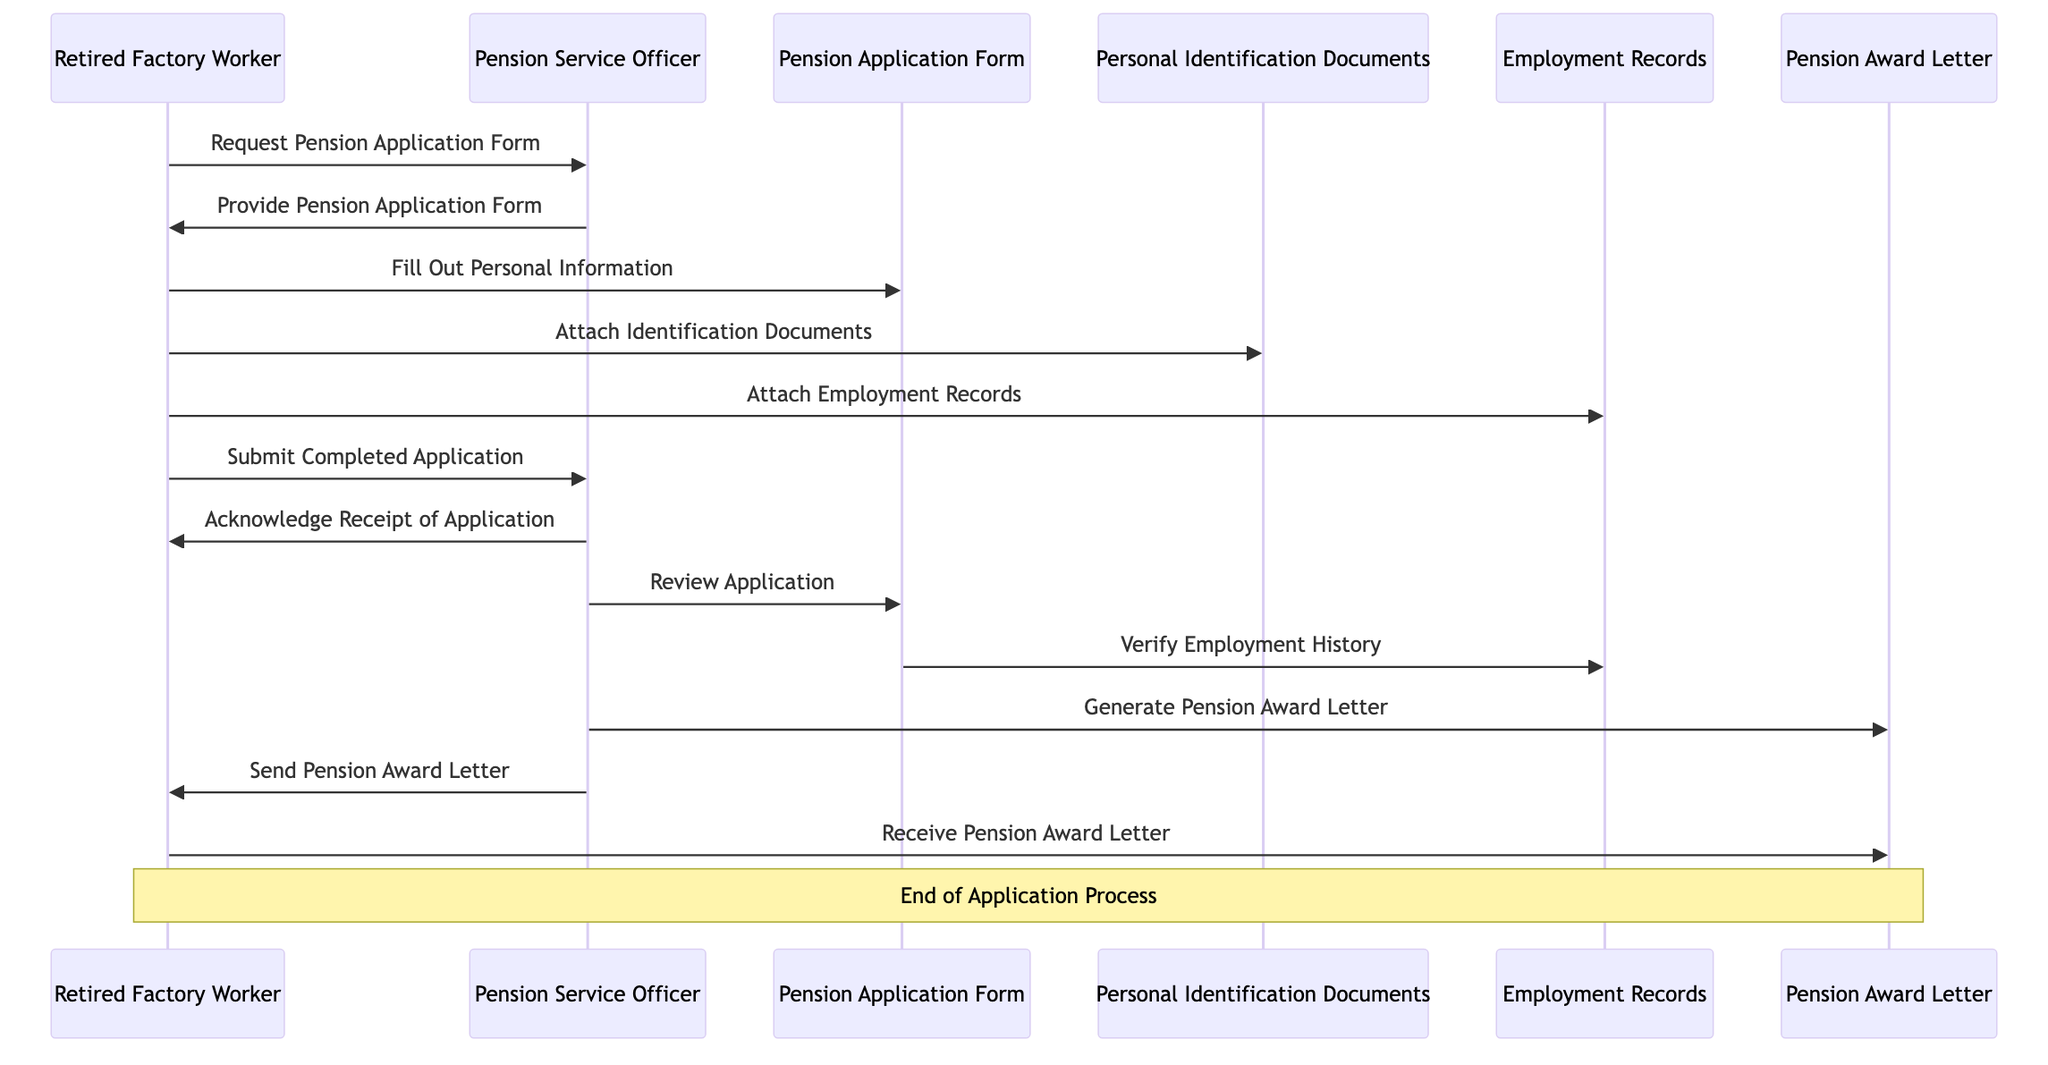What is the first action taken by the Retired Factory Worker? The first action taken by the Retired Factory Worker in the diagram is to "Request Pension Application Form," which initiates the application process.
Answer: Request Pension Application Form How many objects are involved in the application process? The diagram lists four objects: Pension Application Form, Personal Identification Documents, Employment Records, and Pension Award Letter. Therefore, the total number of objects is four.
Answer: 4 What does the Pension Service Officer do after acknowledging receipt of the application? After acknowledging receipt of the application, the Pension Service Officer reviews the application to ensure all necessary information is provided before proceeding to generate the Pension Award Letter.
Answer: Review Application Which document requires verification of employment history? The Pension Application Form is responsible for verifying the Employment Records to confirm the applicant's employment history.
Answer: Employment Records How many messages are exchanged between the actors in total? By counting all the messages in the sequence diagram, we find that a total of eleven messages are exchanged between the Retired Factory Worker and the Pension Service Officer.
Answer: 11 What is the last action taken by the Retired Factory Worker? The last action taken by the Retired Factory Worker in the sequence is "Receive Pension Award Letter," which concludes the application process.
Answer: Receive Pension Award Letter What role does the Pension Service Officer play in generating the Pension Award Letter? The Pension Service Officer is responsible for generating the Pension Award Letter after reviewing and verifying the application details. They create and then send this letter to the Retired Factory Worker.
Answer: Generate Pension Award Letter Which documents does the Retired Factory Worker attach? The Retired Factory Worker attaches Personal Identification Documents and Employment Records to the Pension Application Form as part of the application process.
Answer: Personal Identification Documents, Employment Records What is the purpose of reviewing the application? The purpose of reviewing the application is to ensure that all information is correct and complete before the Pension Service Officer generates the Pension Award Letter for the Retired Factory Worker.
Answer: Ensure correctness and completeness 